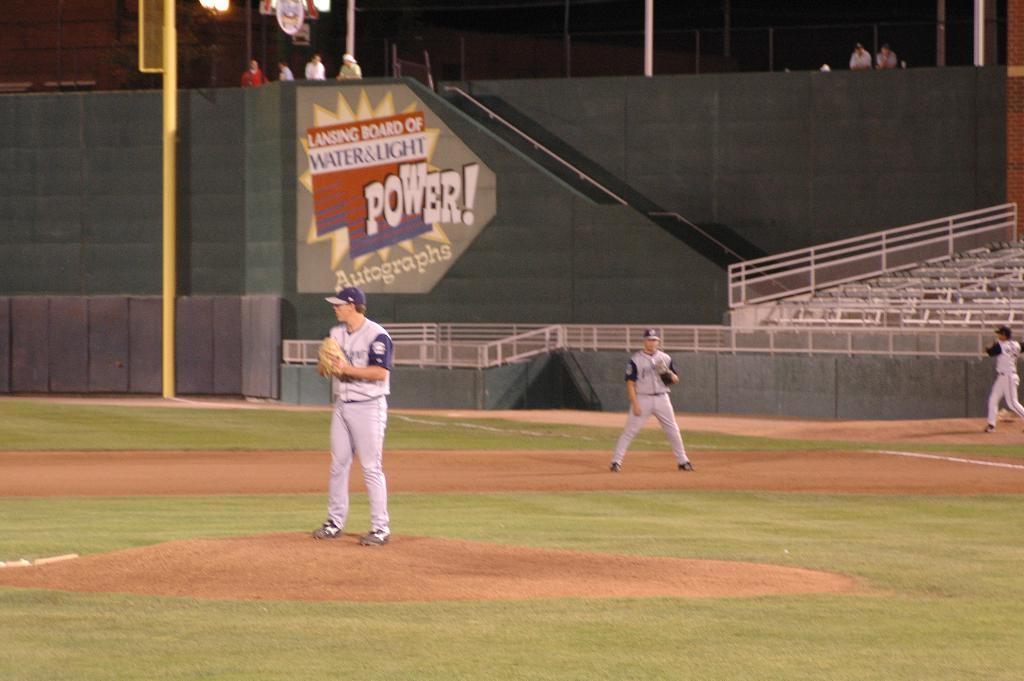<image>
Give a short and clear explanation of the subsequent image. A pitcher on the mound of a baseball field in front of a green wall with a sign for Power! photographs 